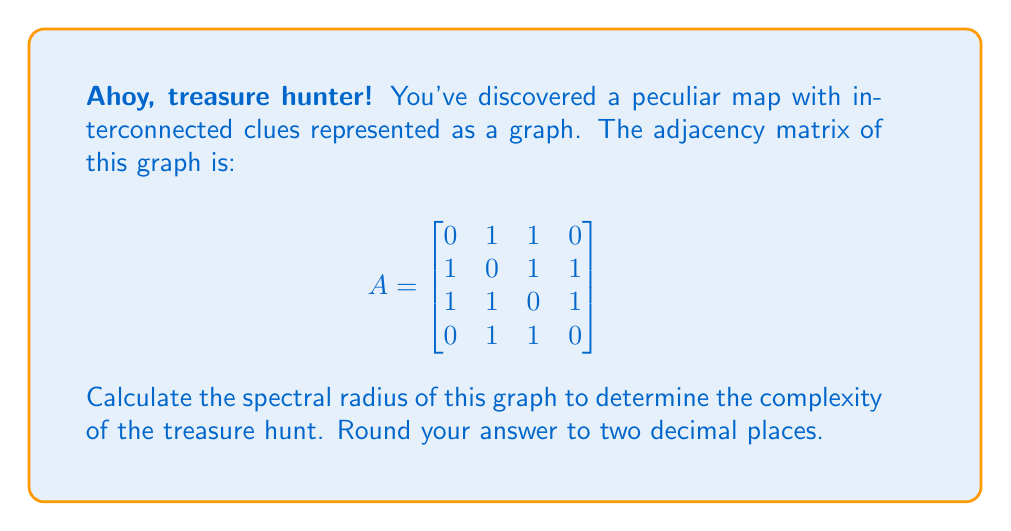Solve this math problem. Let's approach this step-by-step:

1) The spectral radius of a graph is the largest absolute eigenvalue of its adjacency matrix.

2) To find the eigenvalues, we need to solve the characteristic equation:
   $$det(A - \lambda I) = 0$$

3) Expanding this determinant:
   $$\begin{vmatrix}
   -\lambda & 1 & 1 & 0 \\
   1 & -\lambda & 1 & 1 \\
   1 & 1 & -\lambda & 1 \\
   0 & 1 & 1 & -\lambda
   \end{vmatrix} = 0$$

4) This expands to the characteristic polynomial:
   $$\lambda^4 - 3\lambda^2 - 2\lambda + 1 = 0$$

5) This is a fourth-degree polynomial, which is difficult to solve by hand. However, we can use numerical methods or a computer algebra system to find the roots.

6) The roots (eigenvalues) are approximately:
   $\lambda_1 \approx 2.17$
   $\lambda_2 \approx 0.74$
   $\lambda_3 \approx -1.00$
   $\lambda_4 \approx -0.91$

7) The spectral radius is the largest absolute value among these eigenvalues, which is $|\lambda_1| \approx 2.17$.

8) Rounding to two decimal places, we get 2.17.
Answer: 2.17 